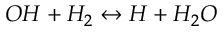<formula> <loc_0><loc_0><loc_500><loc_500>O H + H _ { 2 } \leftrightarrow H + H _ { 2 } O</formula> 